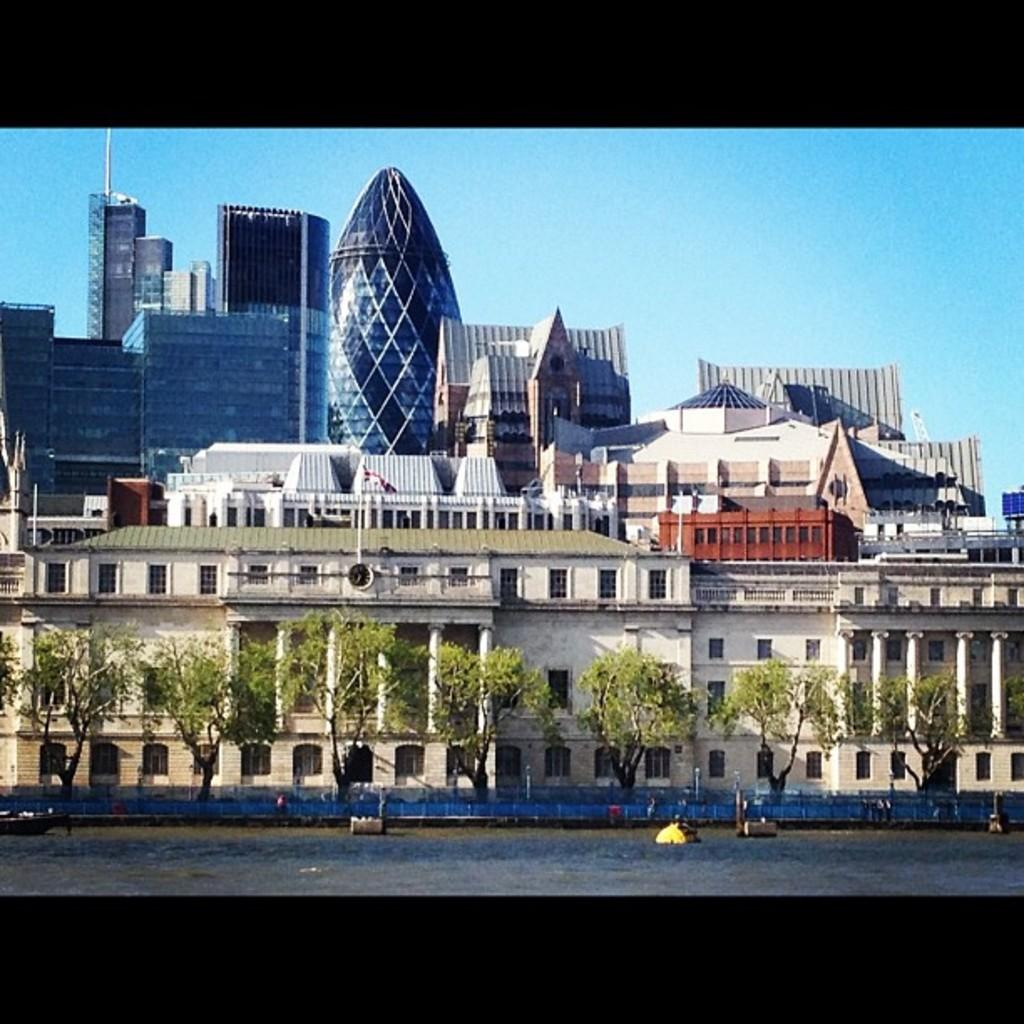What type of vegetation is visible in the image? There are trees in front of buildings in the image. What can be seen on the water in the image? There are objects floating on the water in the image. What is visible at the top of the image? The sky is visible at the top of the image. How many calculators can be seen on the beds in the image? There are no calculators or beds present in the image. What type of earth is visible in the image? There is no specific type of earth visible in the image; it features trees, buildings, water, and sky. 